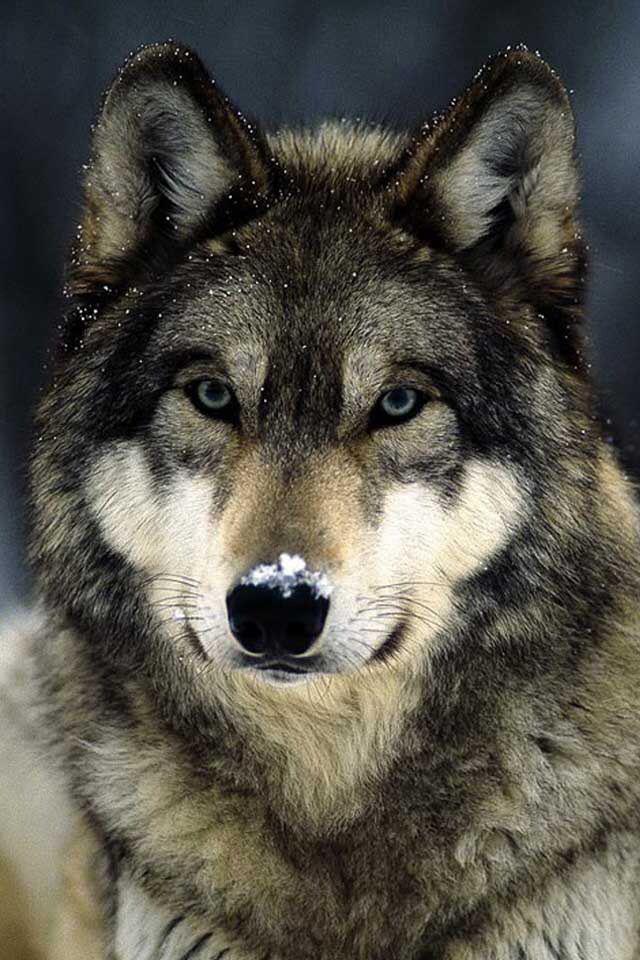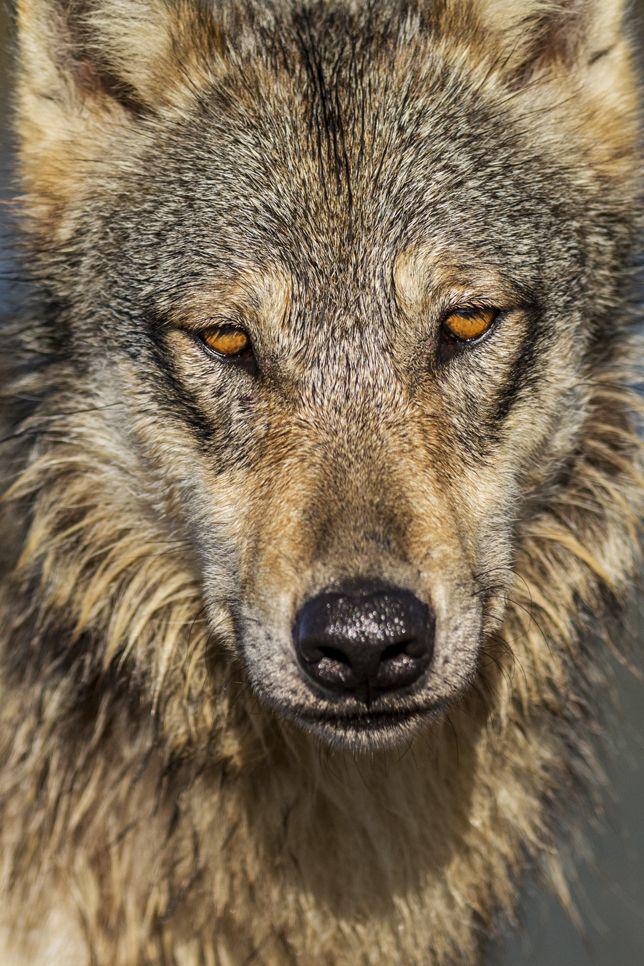The first image is the image on the left, the second image is the image on the right. Examine the images to the left and right. Is the description "In one of the images, there is a wolf that is running." accurate? Answer yes or no. No. The first image is the image on the left, the second image is the image on the right. For the images shown, is this caption "The combined images include two wolves in running poses." true? Answer yes or no. No. 